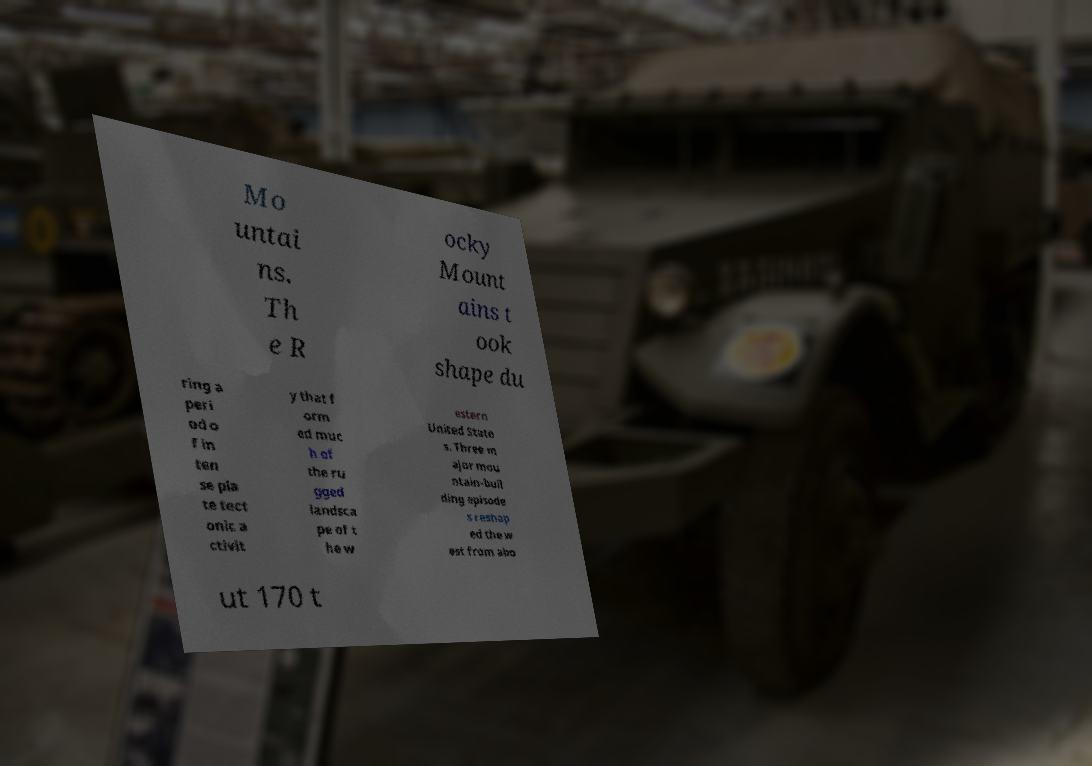Can you read and provide the text displayed in the image?This photo seems to have some interesting text. Can you extract and type it out for me? Mo untai ns. Th e R ocky Mount ains t ook shape du ring a peri od o f in ten se pla te tect onic a ctivit y that f orm ed muc h of the ru gged landsca pe of t he w estern United State s. Three m ajor mou ntain-buil ding episode s reshap ed the w est from abo ut 170 t 